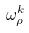Convert formula to latex. <formula><loc_0><loc_0><loc_500><loc_500>\omega _ { \rho } ^ { k }</formula> 